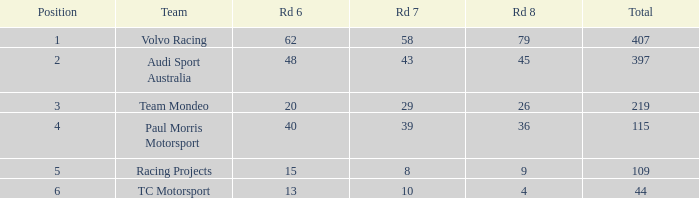For tc motorsport in a position above 1, what is the combined value of rd 7 when rd 6 is below 48 and rd 8 is under 4? None. 